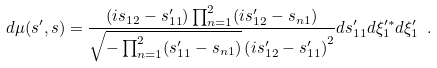Convert formula to latex. <formula><loc_0><loc_0><loc_500><loc_500>d \mu ( s ^ { \prime } , s ) = \frac { ( i s _ { 1 2 } - s _ { 1 1 } ^ { \prime } ) \prod _ { n = 1 } ^ { 2 } ( i s _ { 1 2 } ^ { \prime } - s _ { n 1 } ) } { \sqrt { - \prod _ { n = 1 } ^ { 2 } ( s _ { 1 1 } ^ { \prime } - s _ { n 1 } ) } \left ( i s _ { 1 2 } ^ { \prime } - s _ { 1 1 } ^ { \prime } \right ) ^ { 2 } } d s _ { 1 1 } ^ { \prime } d \xi _ { 1 } ^ { \prime * } d \xi _ { 1 } ^ { \prime } \ .</formula> 